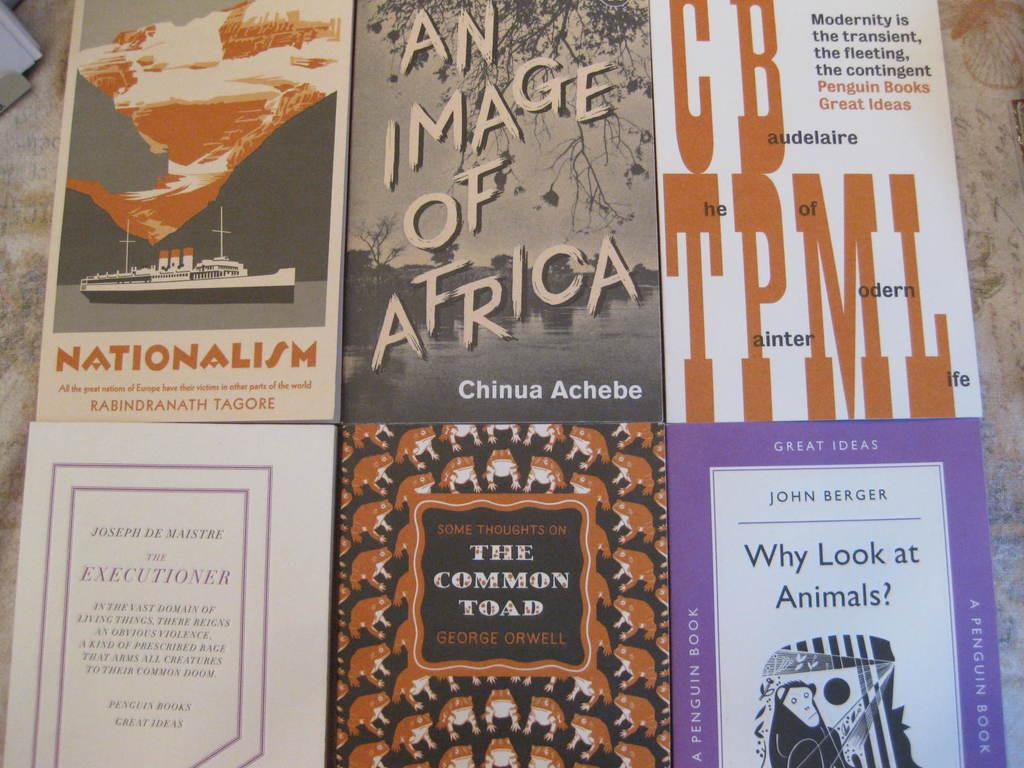<image>
Create a compact narrative representing the image presented. A book titled Nationalism is surrounded by other books. 